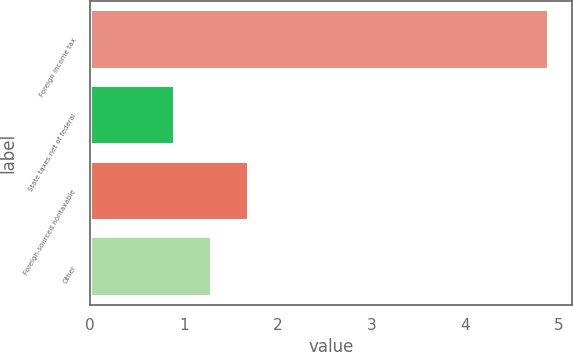<chart> <loc_0><loc_0><loc_500><loc_500><bar_chart><fcel>Foreign income tax<fcel>State taxes net of federal<fcel>Foreign-sourced nontaxable<fcel>Other<nl><fcel>4.9<fcel>0.9<fcel>1.7<fcel>1.3<nl></chart> 